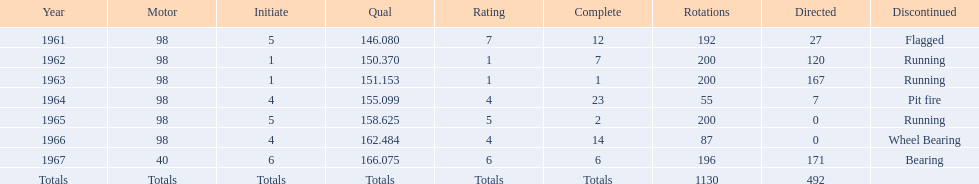How many total laps have been driven in the indy 500? 1130. 